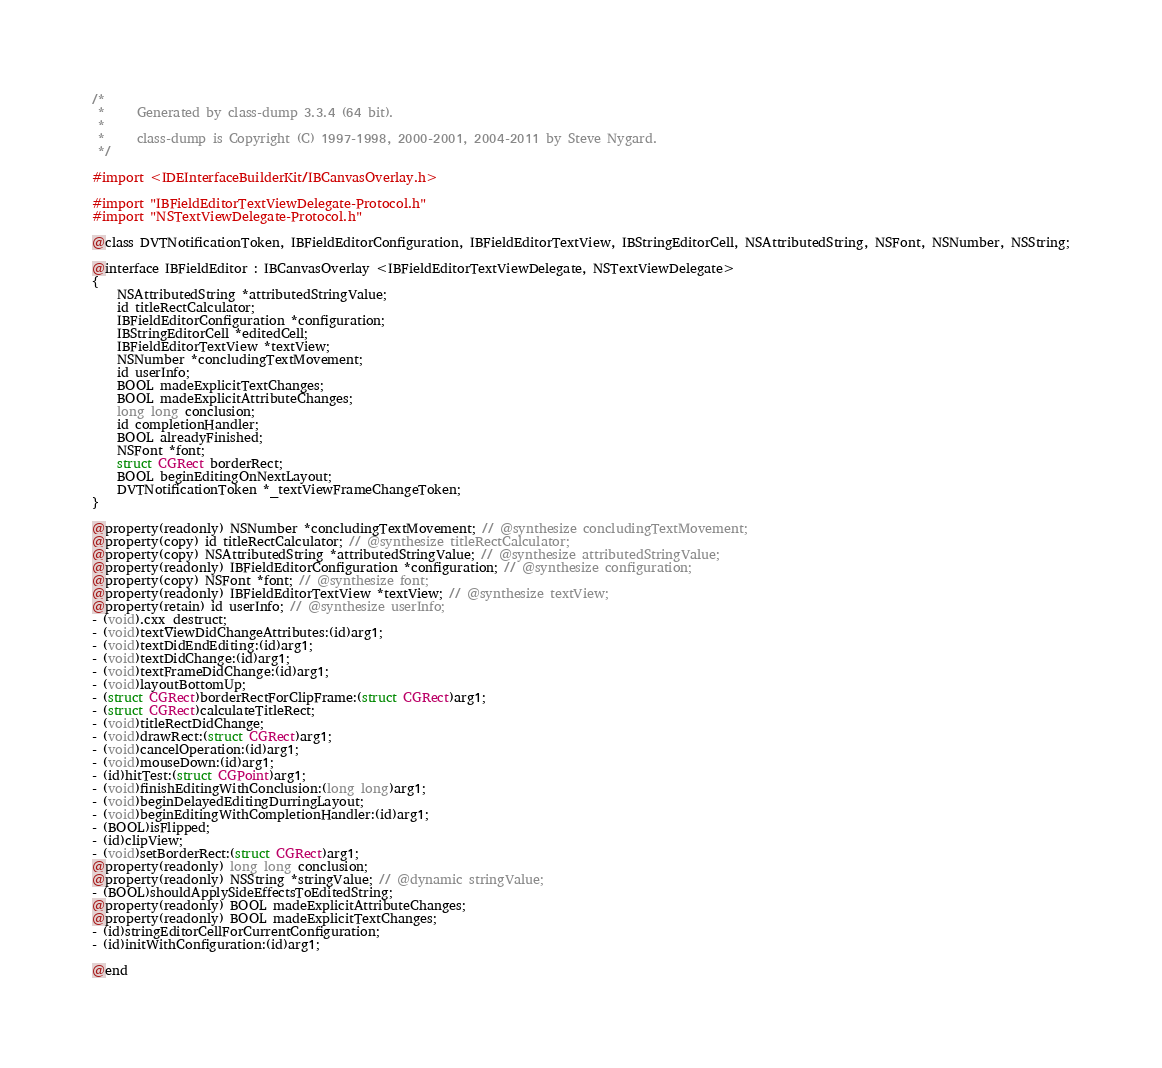Convert code to text. <code><loc_0><loc_0><loc_500><loc_500><_C_>/*
 *     Generated by class-dump 3.3.4 (64 bit).
 *
 *     class-dump is Copyright (C) 1997-1998, 2000-2001, 2004-2011 by Steve Nygard.
 */

#import <IDEInterfaceBuilderKit/IBCanvasOverlay.h>

#import "IBFieldEditorTextViewDelegate-Protocol.h"
#import "NSTextViewDelegate-Protocol.h"

@class DVTNotificationToken, IBFieldEditorConfiguration, IBFieldEditorTextView, IBStringEditorCell, NSAttributedString, NSFont, NSNumber, NSString;

@interface IBFieldEditor : IBCanvasOverlay <IBFieldEditorTextViewDelegate, NSTextViewDelegate>
{
    NSAttributedString *attributedStringValue;
    id titleRectCalculator;
    IBFieldEditorConfiguration *configuration;
    IBStringEditorCell *editedCell;
    IBFieldEditorTextView *textView;
    NSNumber *concludingTextMovement;
    id userInfo;
    BOOL madeExplicitTextChanges;
    BOOL madeExplicitAttributeChanges;
    long long conclusion;
    id completionHandler;
    BOOL alreadyFinished;
    NSFont *font;
    struct CGRect borderRect;
    BOOL beginEditingOnNextLayout;
    DVTNotificationToken *_textViewFrameChangeToken;
}

@property(readonly) NSNumber *concludingTextMovement; // @synthesize concludingTextMovement;
@property(copy) id titleRectCalculator; // @synthesize titleRectCalculator;
@property(copy) NSAttributedString *attributedStringValue; // @synthesize attributedStringValue;
@property(readonly) IBFieldEditorConfiguration *configuration; // @synthesize configuration;
@property(copy) NSFont *font; // @synthesize font;
@property(readonly) IBFieldEditorTextView *textView; // @synthesize textView;
@property(retain) id userInfo; // @synthesize userInfo;
- (void).cxx_destruct;
- (void)textViewDidChangeAttributes:(id)arg1;
- (void)textDidEndEditing:(id)arg1;
- (void)textDidChange:(id)arg1;
- (void)textFrameDidChange:(id)arg1;
- (void)layoutBottomUp;
- (struct CGRect)borderRectForClipFrame:(struct CGRect)arg1;
- (struct CGRect)calculateTitleRect;
- (void)titleRectDidChange;
- (void)drawRect:(struct CGRect)arg1;
- (void)cancelOperation:(id)arg1;
- (void)mouseDown:(id)arg1;
- (id)hitTest:(struct CGPoint)arg1;
- (void)finishEditingWithConclusion:(long long)arg1;
- (void)beginDelayedEditingDurringLayout;
- (void)beginEditingWithCompletionHandler:(id)arg1;
- (BOOL)isFlipped;
- (id)clipView;
- (void)setBorderRect:(struct CGRect)arg1;
@property(readonly) long long conclusion;
@property(readonly) NSString *stringValue; // @dynamic stringValue;
- (BOOL)shouldApplySideEffectsToEditedString;
@property(readonly) BOOL madeExplicitAttributeChanges;
@property(readonly) BOOL madeExplicitTextChanges;
- (id)stringEditorCellForCurrentConfiguration;
- (id)initWithConfiguration:(id)arg1;

@end

</code> 